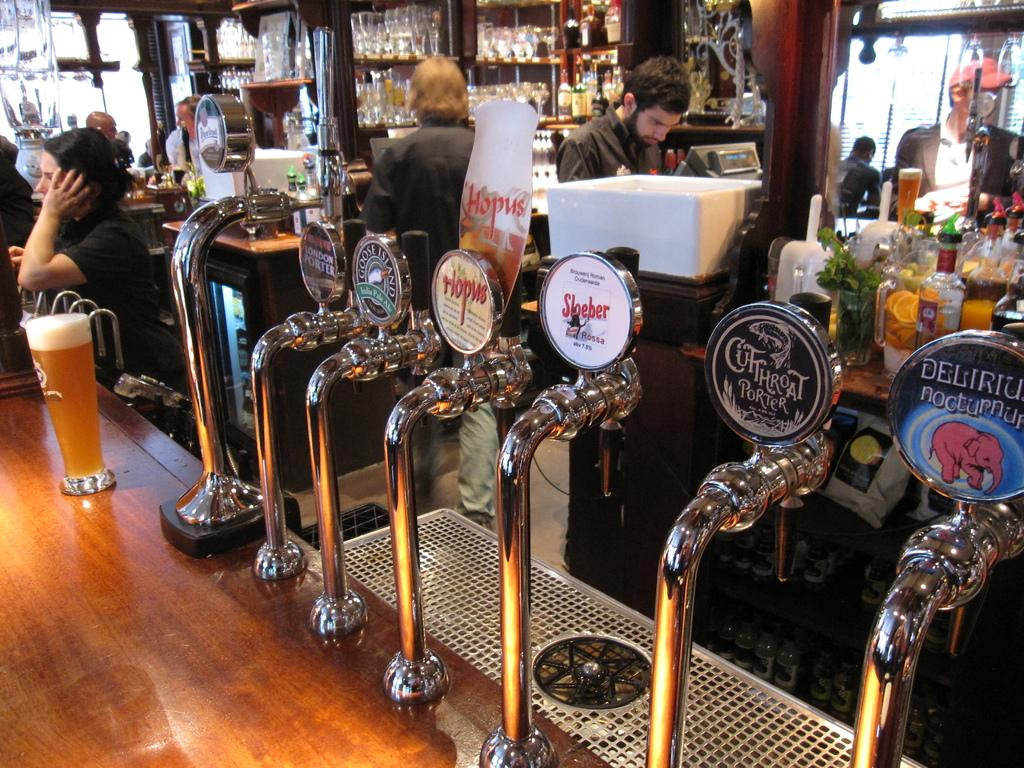<image>
Write a terse but informative summary of the picture. Beer hands in a bar with Sloeber beer in the middle. 